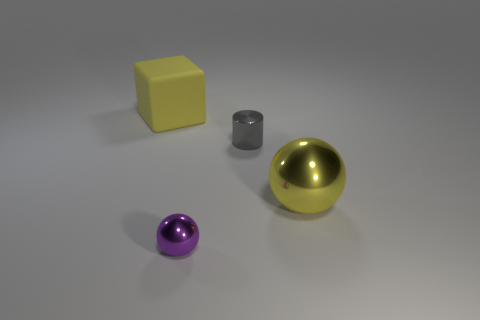Add 2 small green rubber objects. How many objects exist? 6 Subtract all blocks. How many objects are left? 3 Add 4 large red balls. How many large red balls exist? 4 Subtract 0 brown cubes. How many objects are left? 4 Subtract all large matte cubes. Subtract all gray metal cylinders. How many objects are left? 2 Add 3 purple metal things. How many purple metal things are left? 4 